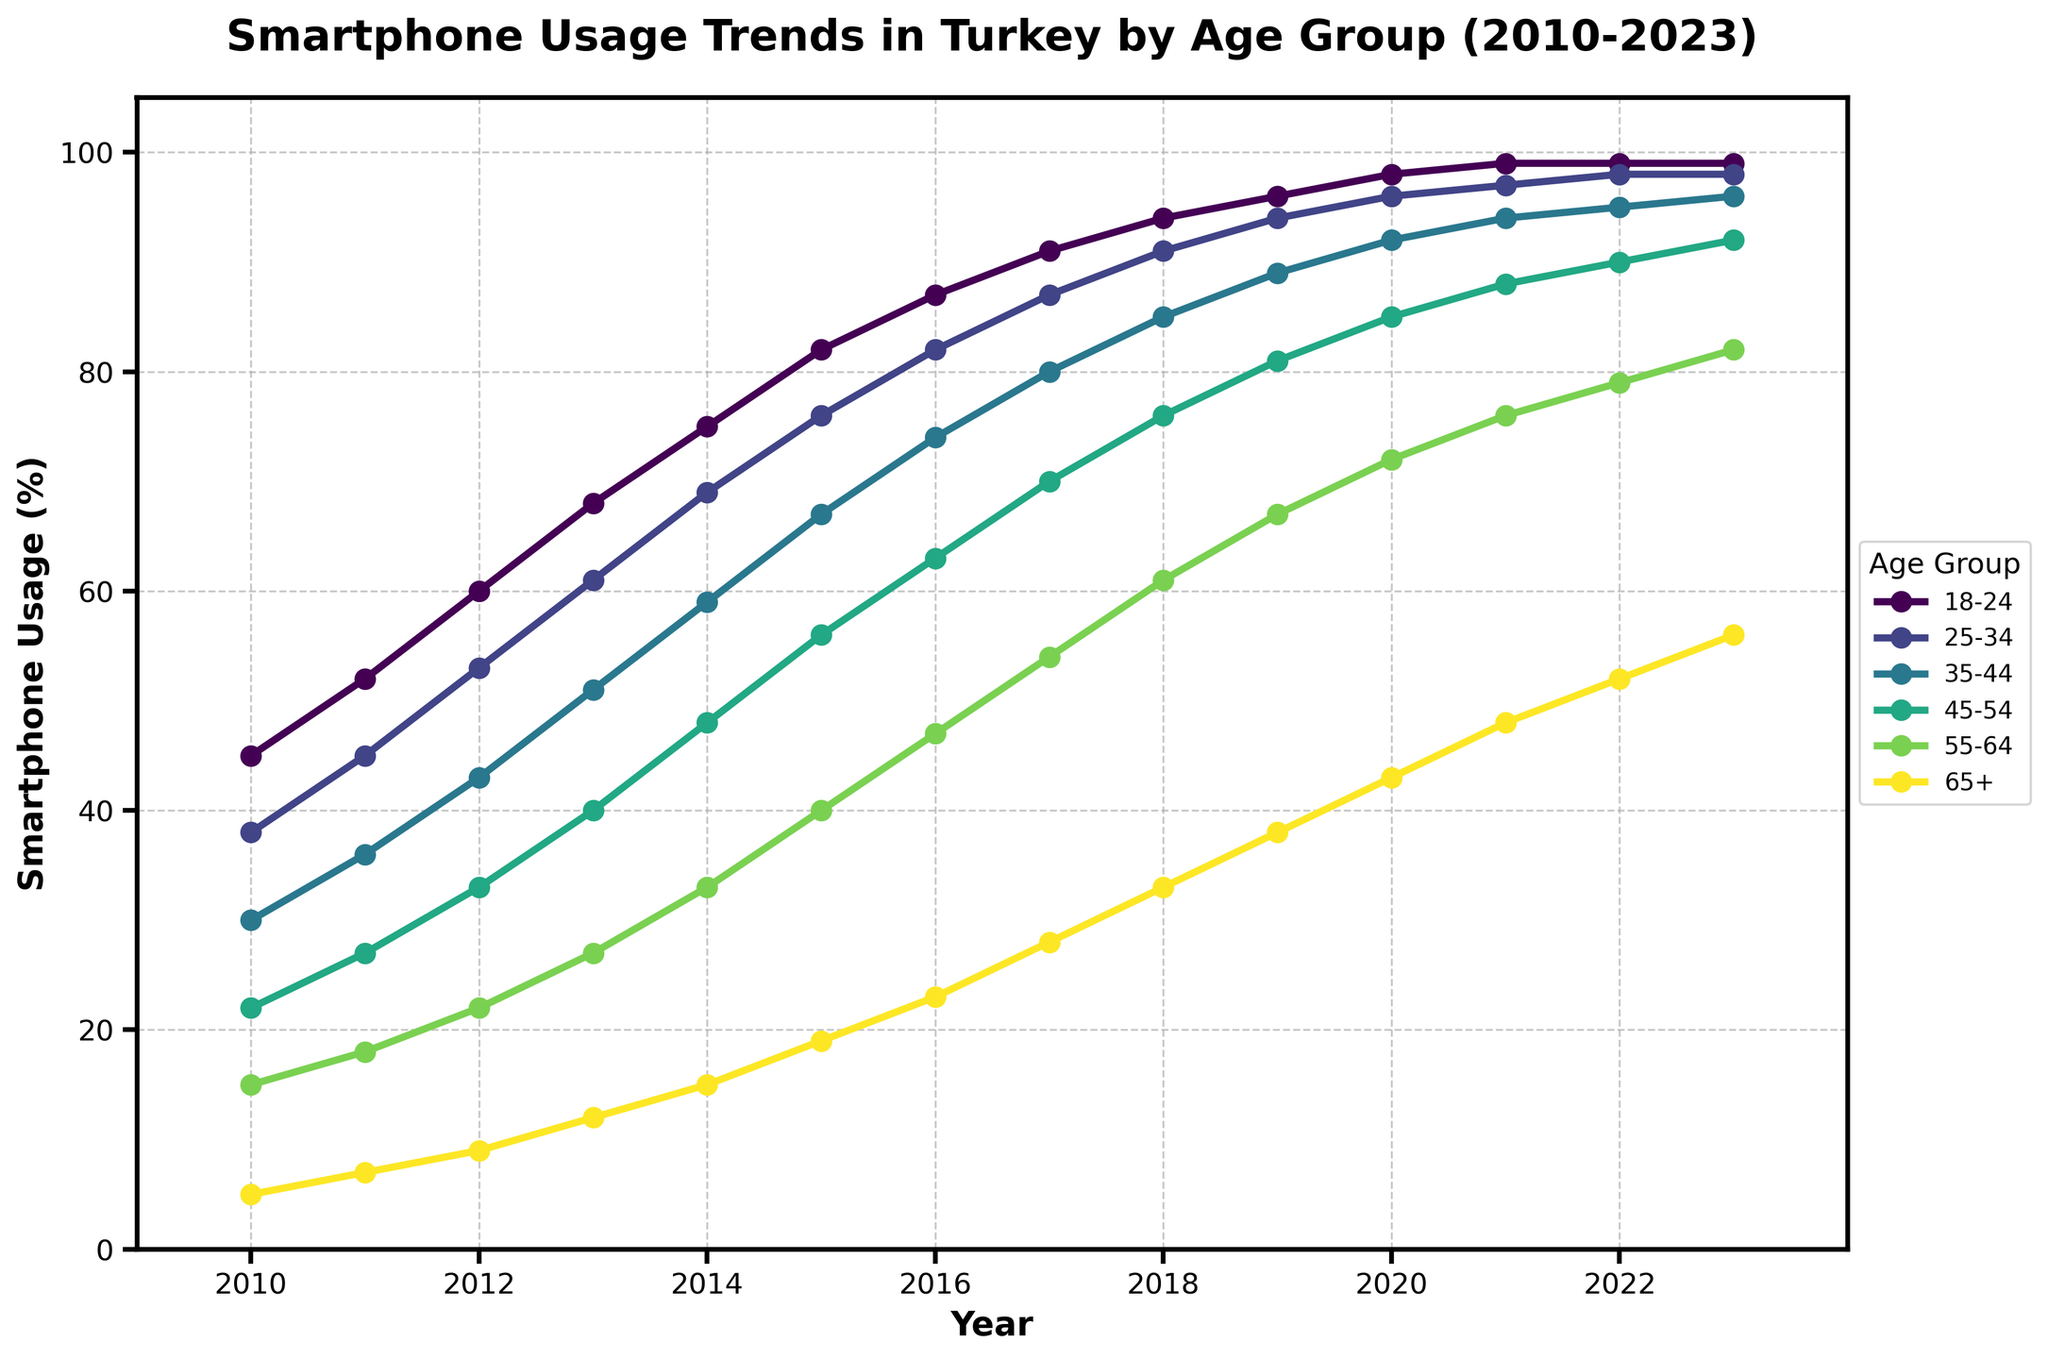What is the trend in smartphone usage for the 25-34 age group from 2010 to 2023? The data shows an increasing trend in smartphone usage for the 25-34 age group from 38% in 2010 to 98% in 2023. The usage of smartphones consistently increased each year during this period.
Answer: Increasing trend Which age group had the biggest increase in smartphone usage from 2010 to 2023? To find this, we look at the difference in smartphone usage for each age group between 2010 and 2023. The differences are 54% for 18-24, 60% for 25-34, 66% for 35-44, 70% for 45-54, 67% for 55-64, and 51% for 65+. The 45-54 age group had the biggest increase.
Answer: 45-54 In what year did the 18-24 age group surpass 90% smartphone usage? By examining the data, the 18-24 age group surpasses 90% smartphone usage in 2017 where the value is 91%.
Answer: 2017 Compare the smartphone usage between the 18-24 and 55-64 age groups in 2022. The 18-24 age group has a smartphone usage of 99% while the 55-64 age group has a usage of 79% in 2022. Thus, the 18-24 age group has significantly higher usage.
Answer: 18-24 has higher usage What’s the average smartphone usage for the 65+ age group from 2010 to 2023? Adding the values of the 65+ age group from 2010 to 2023 (5, 7, 9, 12, 15, 19, 23, 28, 33, 38, 43, 48, 52, 56) gives 340. Dividing by 14 (number of years) gives 340/14 ≈ 24.29.
Answer: 24.29 Between which consecutive years did the 35-44 age group see the largest increase in smartphone usage? Looking at the differences for each year, the largest increase is from 2012 to 2013, where the usage increased from 43% to 51%, a difference of 8%.
Answer: 2012 to 2013 What's the median smartphone usage percentage for the 45-54 age group from 2010 to 2023? To find the median, we first list the data for the 45-54 age group from 2010 to 2023 (22, 27, 33, 40, 48, 56, 63, 70, 76, 81, 85, 88, 90, 92) which consists of 14 values. The median is the average of the 7th and 8th values: (63 + 70) / 2 = 66.5.
Answer: 66.5 Which age group reached 90% smartphone usage last and in which year? By observing the data, the 45-54 age group reaches 90% in 2022. Comparing with other groups, the 45-54 age group is the last to reach 90% usage.
Answer: 45-54 in 2022 